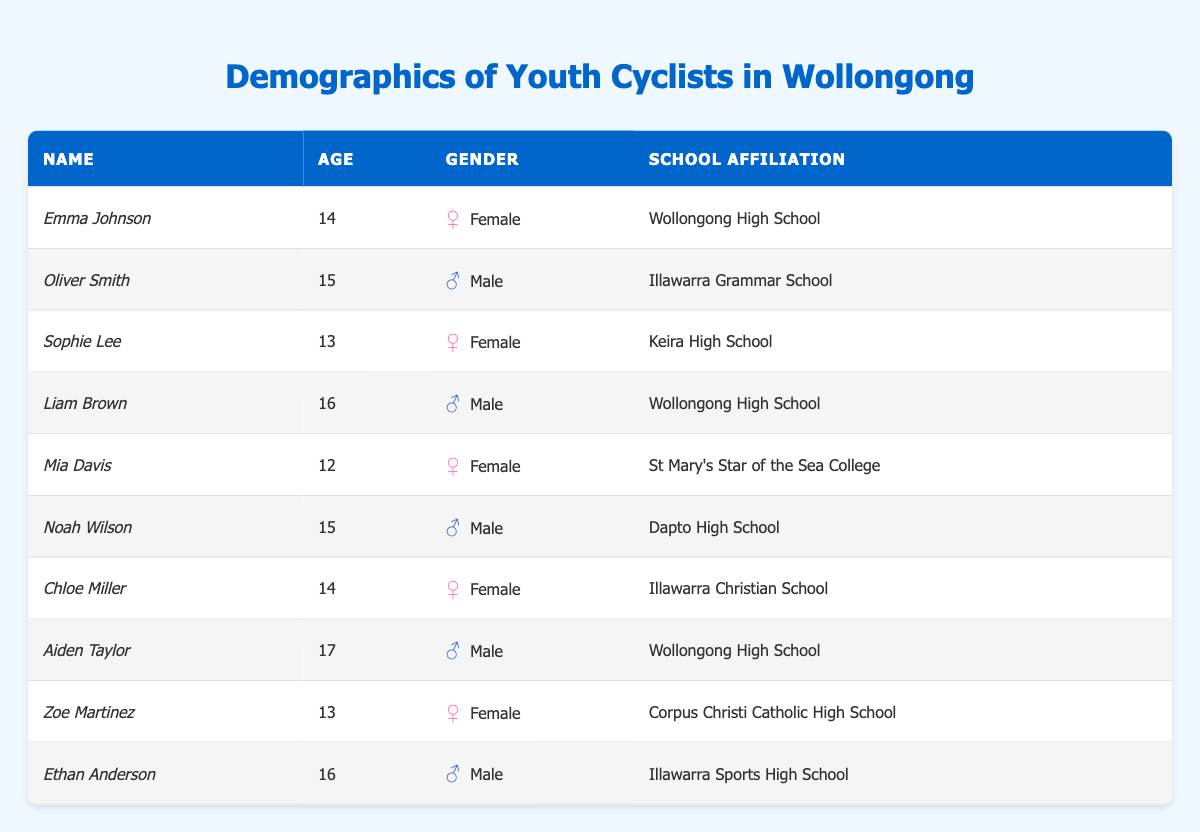What is the age of Emma Johnson? Emma Johnson is listed in the table under the "Name" column and her corresponding age in the "Age" column is directly next to it.
Answer: 14 How many male cyclists are there? By reviewing the "Gender" column, I can count all entries marked as Male. There are 5 entries indicating Male cyclists.
Answer: 5 Which school has the most affiliated cyclists? I will list out the school affiliations from the table. Wollongong High School has 3 cyclists, Illawarra Grammar School has 1, and the rest have either 1 or 2. Therefore, Wollongong High School has the highest number of cyclists affiliated with it.
Answer: Wollongong High School What is the average age of the cyclists? To calculate the average age, I will sum the ages (12 + 13 + 13 + 14 + 14 + 15 + 15 + 16 + 16 + 17 =  13 + 14 + 15 + 15 + 16 + 16 + 17 = 151) and divide by the number of cyclists, which is 10. The average age is 151 / 10 = 15.1.
Answer: 15.1 Is there a cyclist from Corpus Christi Catholic High School? I can scan the "School Affiliation" column for Corpus Christi Catholic High School. There is indeed an entry for Zoe Martinez, confirming there is a cyclist from that school.
Answer: Yes How many cyclists are aged 15 or older? I will list the ages of all cyclists. Ages 15, 16, and 17 are in this data set, and I find that there are 6 cyclists aged 15 or older (Oliver, Noah, Liam, Ethan, Aiden, and one more at 17).
Answer: 6 What percentage of the cyclists are female? There are 5 female cyclists out of the total of 10. To find the percentage, I calculate (5 female / 10 total) * 100, which equals 50%.
Answer: 50% Who are the cyclists associated with Wollongong High School? By looking at the "School Affiliation" column, I can see that there are three entries for Wollongong High School: Emma Johnson, Liam Brown, and Aiden Taylor.
Answer: Emma Johnson, Liam Brown, Aiden Taylor What is the median age of the cyclists? First, I will organize the ages in ascending order: 12, 13, 13, 14, 14, 15, 15, 16, 16, 17. The median is the average of the two middle values (the 5th and 6th youngest): (14 + 15) / 2 = 14.5.
Answer: 14.5 Are all schools represented by only one cyclist? I will check the "School Affiliation" column for counts. Several schools have more than one cyclist (e.g., Wollongong High School), confirming that not all schools are represented by only one cyclist.
Answer: No 